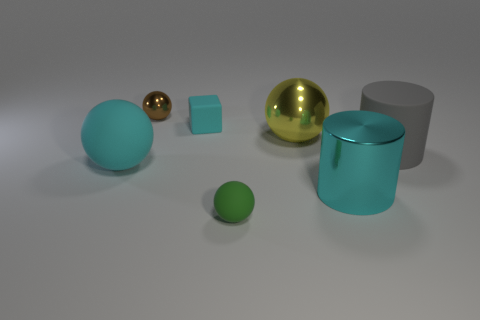Subtract all purple balls. Subtract all blue blocks. How many balls are left? 4 Add 3 small yellow matte spheres. How many objects exist? 10 Subtract all cubes. How many objects are left? 6 Add 1 big green spheres. How many big green spheres exist? 1 Subtract 0 blue cylinders. How many objects are left? 7 Subtract all small yellow cylinders. Subtract all tiny metal spheres. How many objects are left? 6 Add 1 gray cylinders. How many gray cylinders are left? 2 